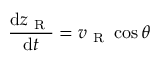Convert formula to latex. <formula><loc_0><loc_0><loc_500><loc_500>\frac { d z _ { R } } { d t } = v _ { R } \cos { \theta }</formula> 